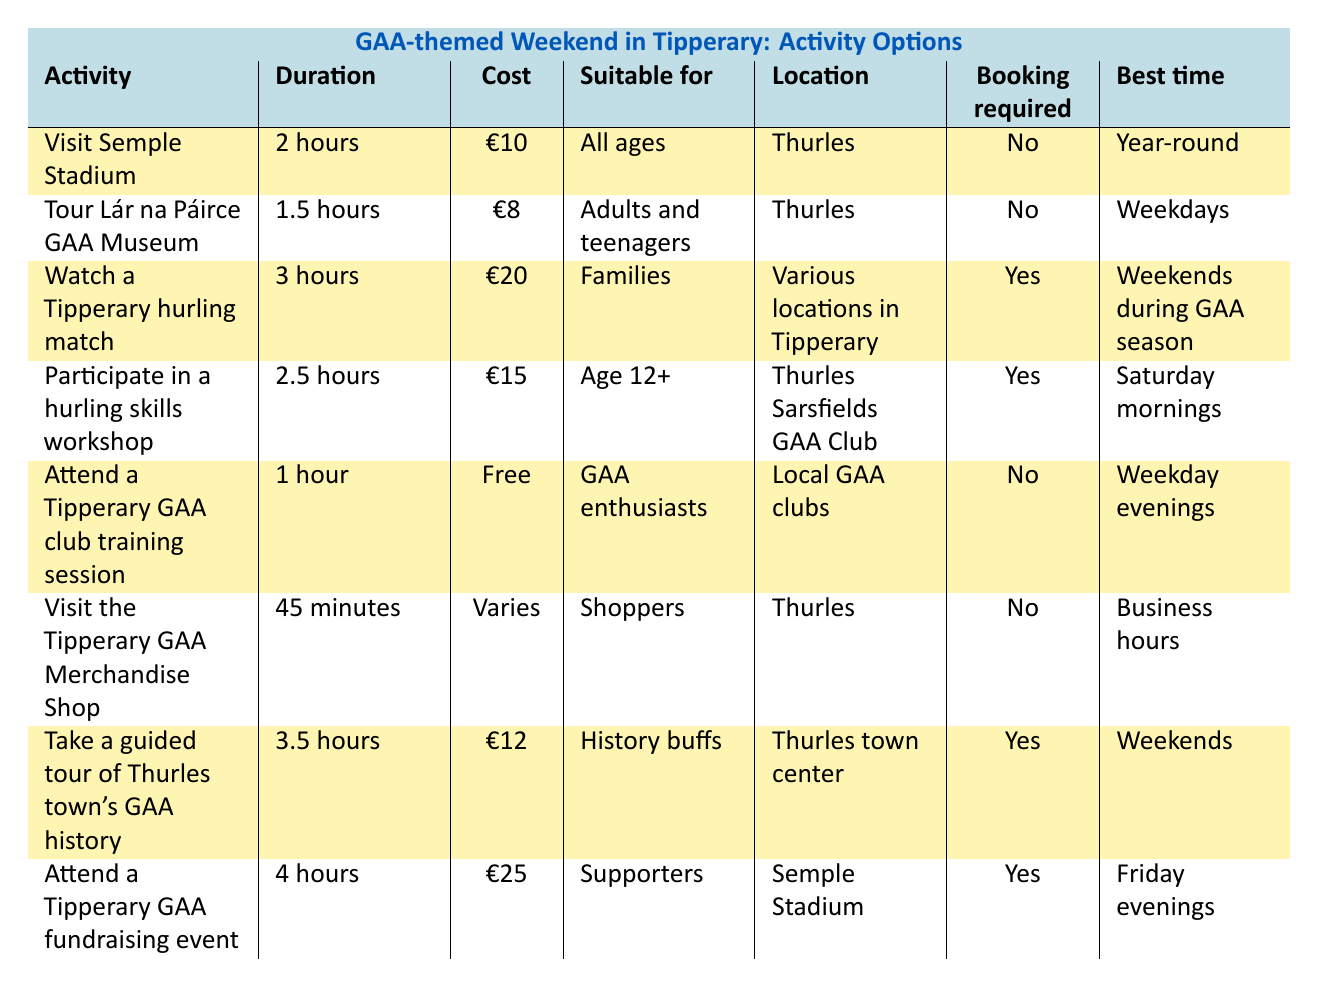What is the duration of the activity "Visit Semple Stadium"? The table lists the duration of "Visit Semple Stadium" as 2 hours in the corresponding row for that activity.
Answer: 2 hours Which activity has the highest cost? By examining the "Cost" column, "Attend a Tipperary GAA fundraising event" has the highest cost at €25.
Answer: €25 Are there any activities that do not require booking? Looking through the "Booking required" column, the activities "Visit Semple Stadium," "Tour Lár na Páirce GAA Museum," "Attend a Tipperary GAA club training session," "Visit the Tipperary GAA Merchandise Shop" are marked as "No," indicating they do not require booking.
Answer: Yes What is the average duration of the activities that require booking? The activities requiring booking are "Watch a Tipperary hurling match" (3 hours), "Participate in a hurling skills workshop" (2.5 hours), "Take a guided tour of Thurles town's GAA history" (3.5 hours), and "Attend a Tipperary GAA fundraising event" (4 hours). The total duration is 3 + 2.5 + 3.5 + 4 = 13 hours. There are 4 activities, so the average duration is 13/4 = 3.25 hours.
Answer: 3.25 hours What age group is suitable for the "Participate in a hurling skills workshop"? The "Suitable for" column specifies that "Participate in a hurling skills workshop" is suitable for "Age 12+."
Answer: Age 12+ Which location has the most activities listed, and how many activities are there? By counting the "Location" column, Thurles appears 5 times for the activities. No other location appears that many times. Therefore, Thurles has the most activities listed, totaling 5 activities.
Answer: Thurles, 5 activities What is the cost difference between the most and least expensive activities? The most expensive activity is "Attend a Tipperary GAA fundraising event" at €25, and the least expensive activity is "Visit the Tipperary GAA Merchandise Shop," which varies in cost but does not have a specific minimum. If we consider a scenario where the shop's item can be €1, the cost difference is €25 - €1 = €24. For a specific value, we would take the lowest item from the variety available.
Answer: €24 Which activity is best to attend on a Saturday morning? The table indicates that "Participate in a hurling skills workshop" is best to attend on Saturday mornings according to the "Best time" column.
Answer: Participate in a hurling skills workshop How many activities are suitable for families? The "Suitable for" column shows that "Watch a Tipperary hurling match" is suitable for families, making it 1 activity.
Answer: 1 activity 